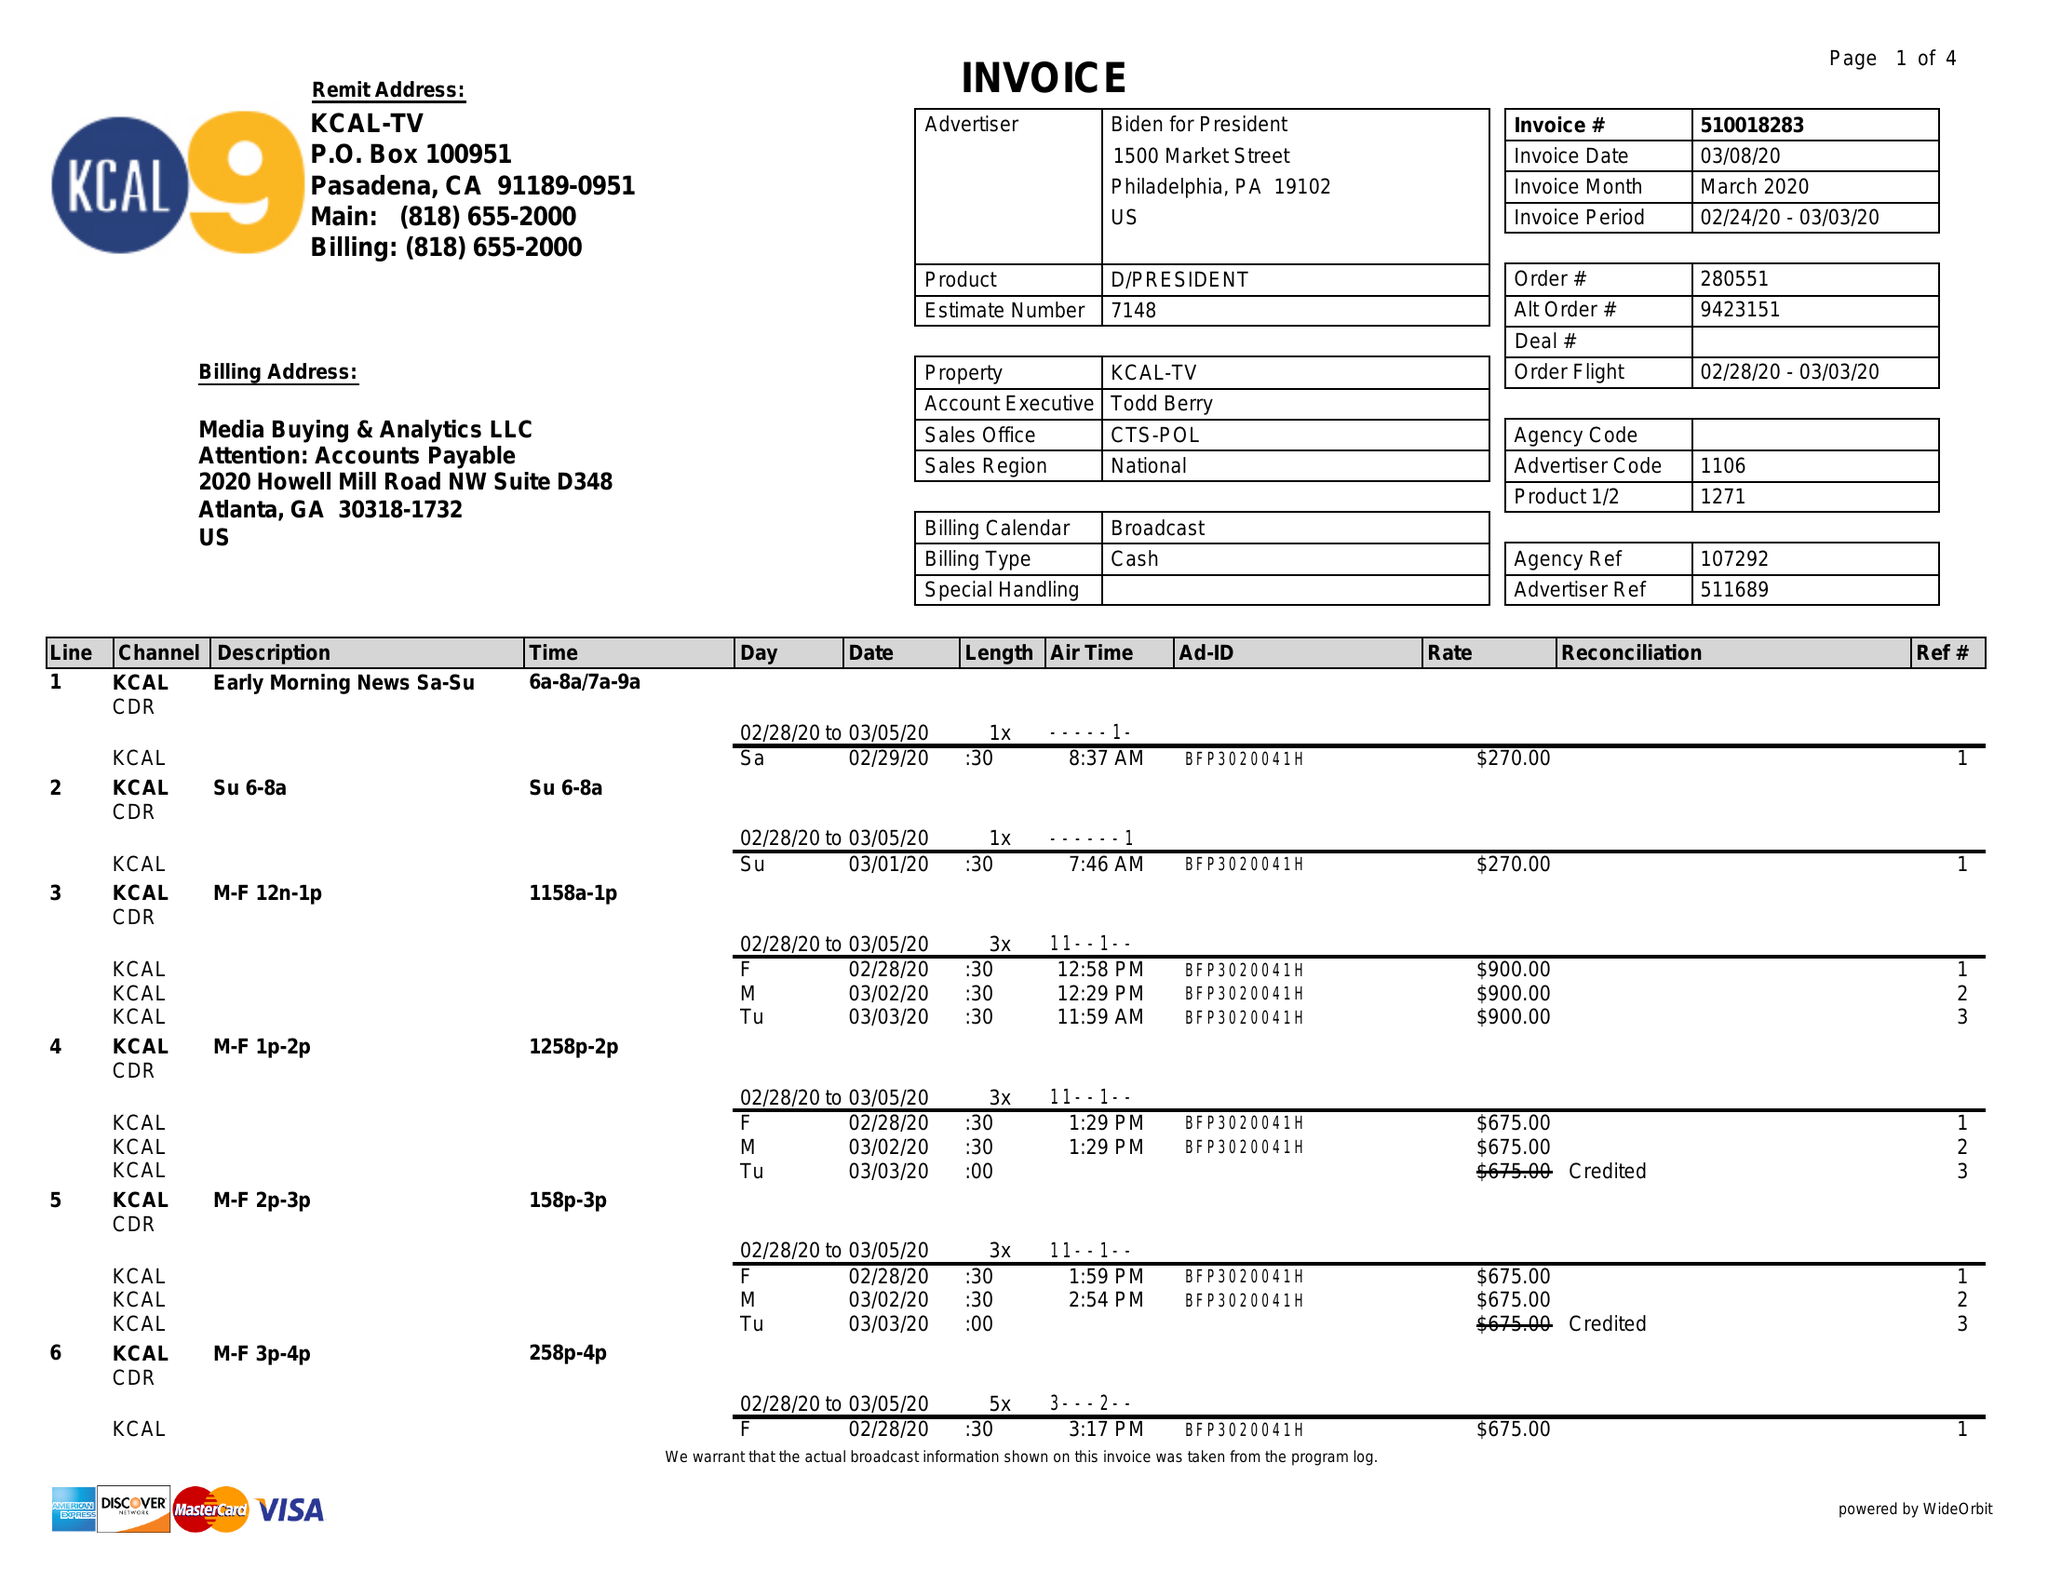What is the value for the flight_to?
Answer the question using a single word or phrase. 03/03/20 